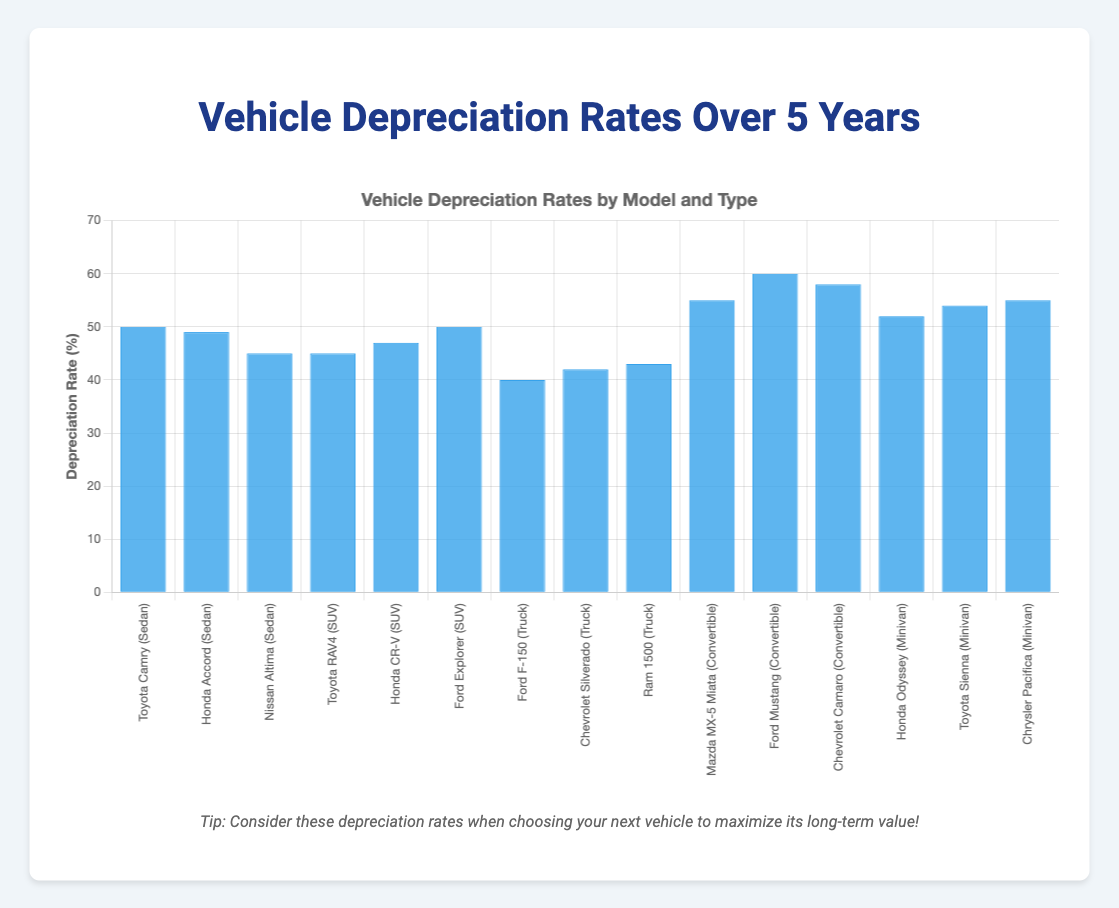Which car type has the highest average depreciation rate? Determine the average for each car type by adding their depreciation rates and dividing by the number of models. Convertibles: (55 + 60 + 58)/3 = 57.67%, Sedans: (50 + 49 + 45)/3 = 48%, SUVs: (45 + 47 + 50)/3 = 47.33%, Trucks: (40 + 42 + 43)/3 = 41.67%, Minivans: (52 + 54 + 55)/3 = 53.67%. The highest average depreciation rate is for Convertibles.
Answer: Convertibles Which model has the lowest depreciation rate? Refer to each bar's height to identify the lowest value. The Ford F-150 has the lowest depreciation rate of 40%.
Answer: Ford F-150 How does the depreciation rate of the Ford Mustang compare to the average depreciation rate of Sedans? The depreciation rate of the Ford Mustang is 60%. The average depreciation rate for Sedans is (50 + 49 + 45)/3 = 48%. Comparing the two, 60% is greater than 48%.
Answer: Greater What is the difference in depreciation rates between the truck with the highest depreciation rate and the sedan with the lowest rate? The highest rate for trucks is the Ram 1500 at 43%. The lowest for sedans is the Nissan Altima at 45%. The difference is 45% - 43% = 2%.
Answer: 2% What is the sum of the depreciation rates of all SUV models? Add the depreciation rates for all SUVs: 45 + 47 + 50 = 142%.
Answer: 142% Which car brand among the convertibles has the highest depreciation rate? Compare the bar heights for the convertibles. The Ford Mustang has the highest at 60%.
Answer: Ford Mustang What is the median depreciation rate for all car models displayed? List all depreciation rates: 50, 49, 45 (Sedans); 45, 47, 50 (SUVs); 40, 42, 43 (Trucks); 55, 60, 58 (Convertibles); 52, 54, 55 (Minivans). Arrange in ascending order: 40, 42, 43, 45, 45, 47, 49, 50, 50, 52, 54, 55, 55, 58, 60. The median (8th value in a list of 15) is 50%.
Answer: 50% What is the visual characteristic of the bar representing the Nissan Altima compared to the Ford Explorer? Visually compare the heights of the bars. The bar for the Ford Explorer is taller (50%) than the bar for the Nissan Altima (45%).
Answer: Taller What is the average depreciation rate for minivans? Add all the depreciation rates for minivans and divide by the number of minivan models: (52 + 54 + 55)/3 = 53.67%.
Answer: 53.67% 